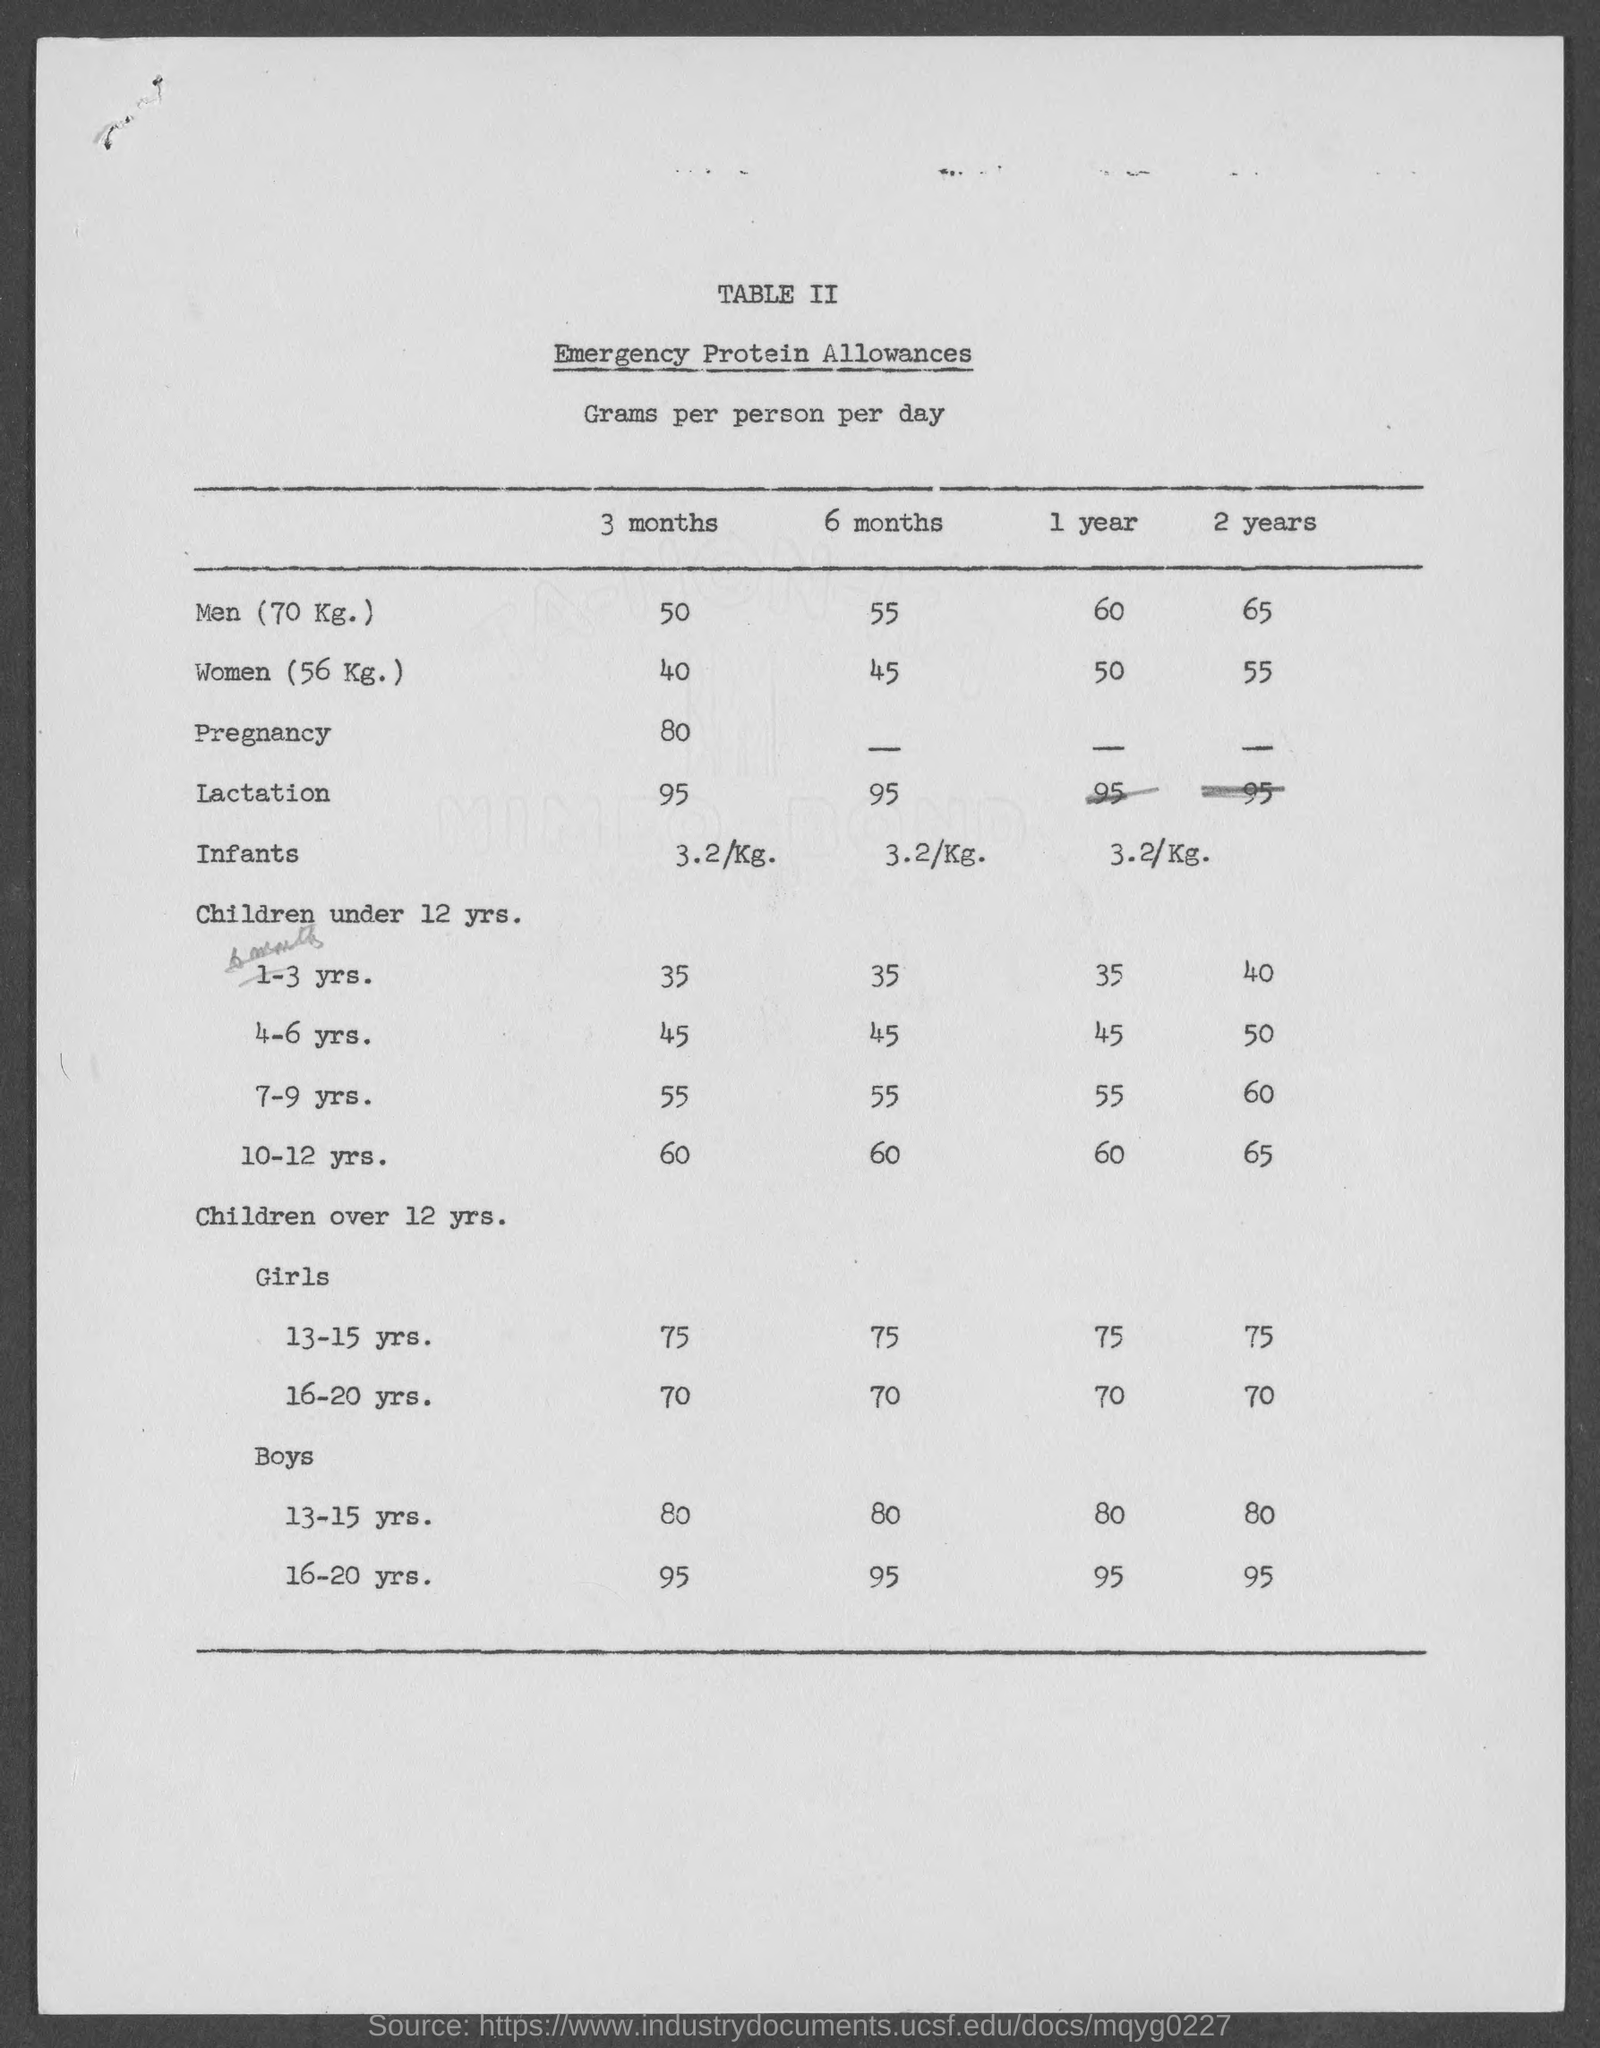What is the title of table ii?
Ensure brevity in your answer.  Emergency Protein Allowances. 